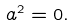Convert formula to latex. <formula><loc_0><loc_0><loc_500><loc_500>a ^ { 2 } = 0 .</formula> 